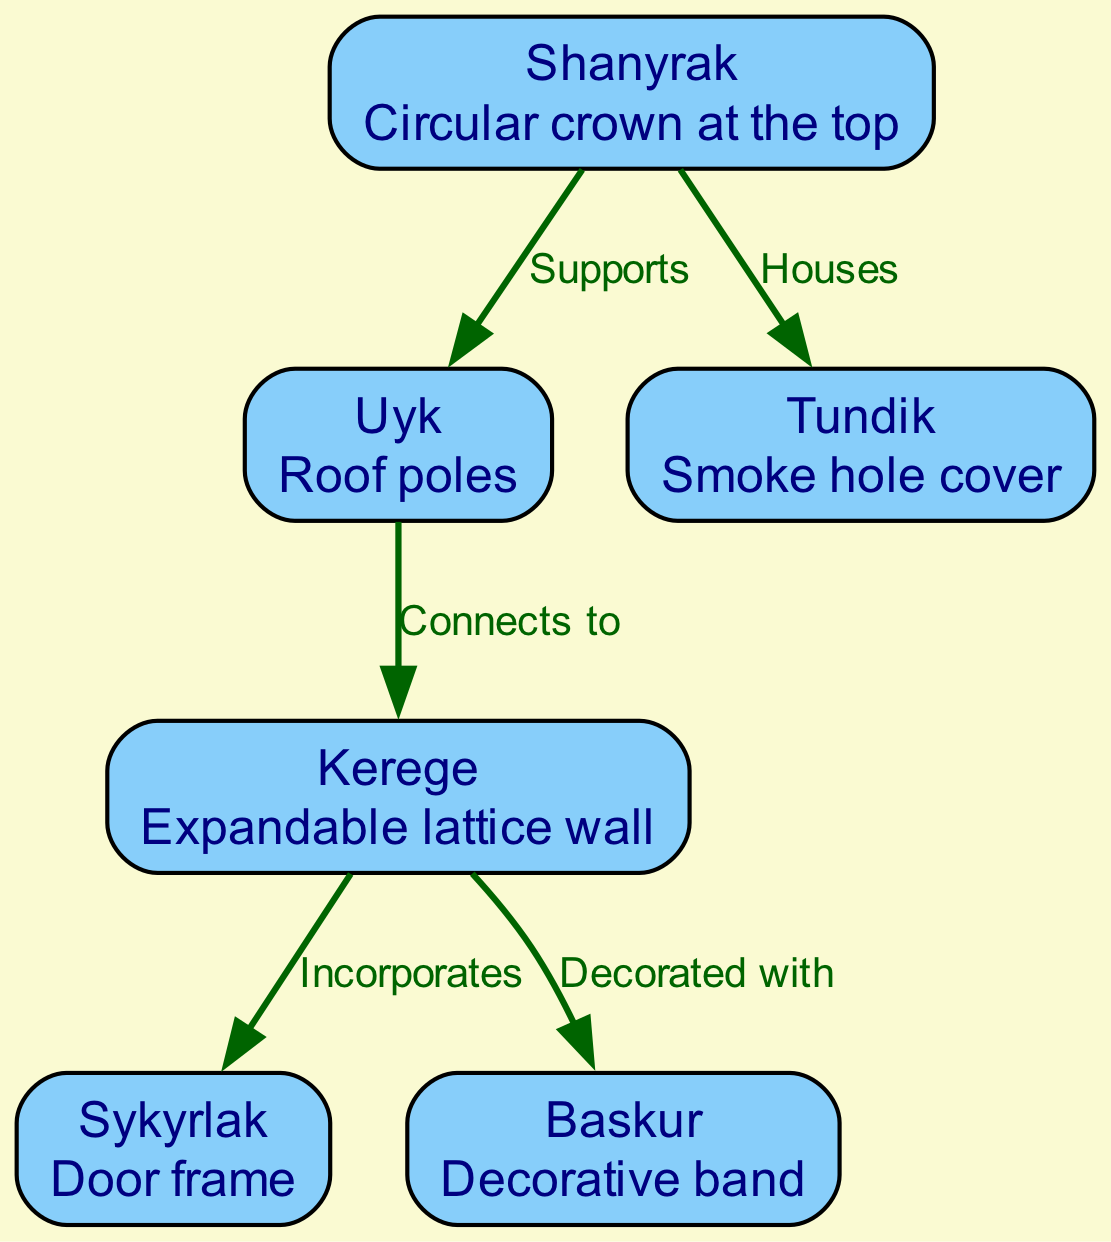What is the main structural component at the top of a yurt? The main structural component at the top of a yurt is the Shanyrak. It is described in the diagram as the circular crown that serves as a key part of the roofing system.
Answer: Shanyrak How many main components are labeled in the diagram? The diagram includes six labeled components of the yurt: Shanyrak, Uyk, Kerege, Sykyrlak, Tundik, and Baskur. By counting the nodes listed, we confirm there are six.
Answer: 6 What connects the roof poles to the lattice wall? The Uyk, which represents the roof poles, connects to the Kerege, the expandable lattice wall, as shown in the edge labeled "Connects to" between these two components.
Answer: Kerege What is the function of the Tundik? The Tundik serves as a smoke hole cover in the yurt structure. This function is indicated in the diagram where the Shanyrak houses the Tundik, highlighting its role in the ventilation system.
Answer: Smoke hole cover Which component is decorated with a decorative band? The Kerege is decorated with the Baskur, as indicated by the edge labeled "Decorated with" in the diagram, showing the relationship between these two elements.
Answer: Baskur What serves as the door frame in the yurt? The Sykyrlak serves as the door frame of the yurt, clearly labeled and described in the diagram as a crucial entryway structure.
Answer: Sykyrlak What supports the circular crown in the yurt? The Uyk, which consists of the roof poles, supports the Shanyrak, as shown in the edge labeled "Supports" connecting these two parts of the structure.
Answer: Uyk How does the Shanyrak interact with the smoke hole cover? The Shanyrak houses the Tundik, meaning that it provides the space or structure for the smoke hole cover. This interaction is depicted in the edge labeled "Houses".
Answer: Houses What is the relationship between Kerege and Sykyrlak? The Kerege incorporates the Sykyrlak, as highlighted in the edge labeled "Incorporates" in the diagram, indicating that the lattice wall is built to include the door frame.
Answer: Incorporates 